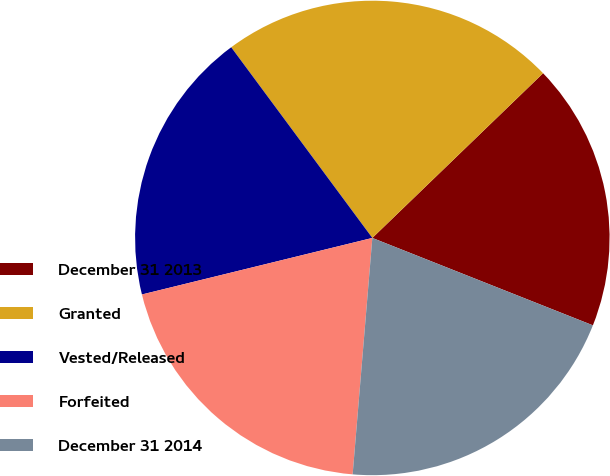Convert chart to OTSL. <chart><loc_0><loc_0><loc_500><loc_500><pie_chart><fcel>December 31 2013<fcel>Granted<fcel>Vested/Released<fcel>Forfeited<fcel>December 31 2014<nl><fcel>18.22%<fcel>22.93%<fcel>18.69%<fcel>19.85%<fcel>20.32%<nl></chart> 